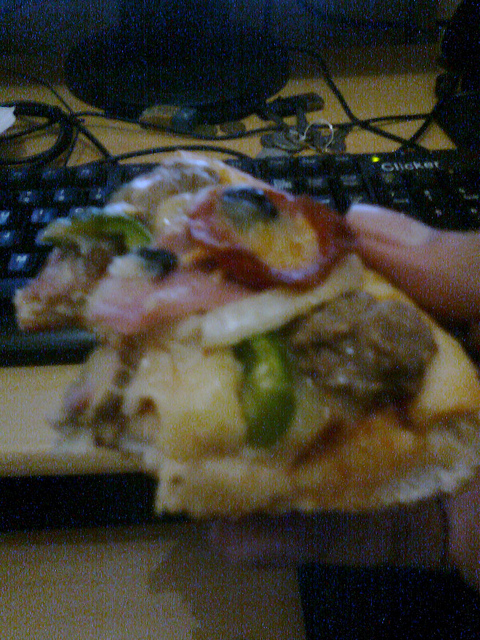Where is the person sitting? The setting suggests a desk area, indicated by the presence of a computer keyboard in the background. 